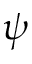Convert formula to latex. <formula><loc_0><loc_0><loc_500><loc_500>\psi</formula> 